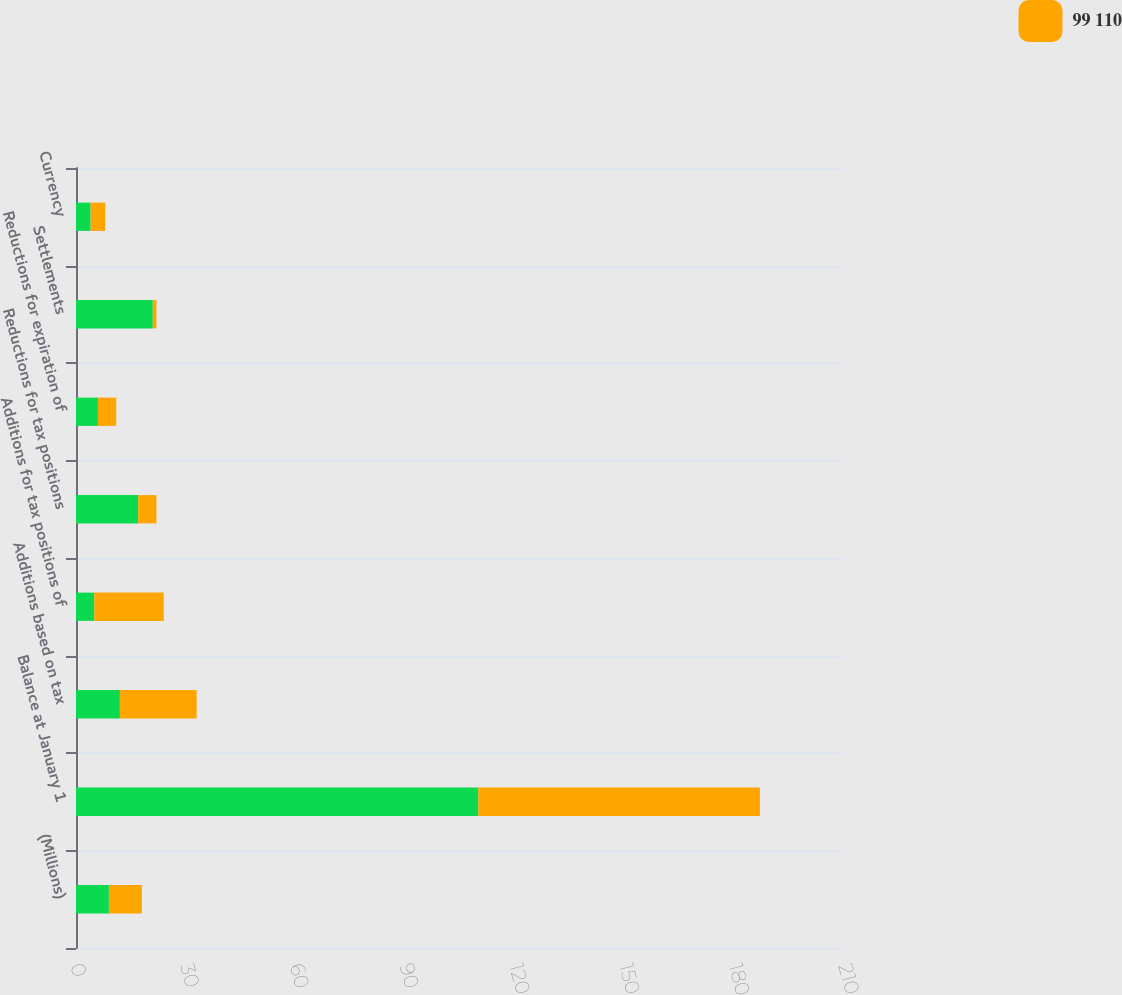Convert chart to OTSL. <chart><loc_0><loc_0><loc_500><loc_500><stacked_bar_chart><ecel><fcel>(Millions)<fcel>Balance at January 1<fcel>Additions based on tax<fcel>Additions for tax positions of<fcel>Reductions for tax positions<fcel>Reductions for expiration of<fcel>Settlements<fcel>Currency<nl><fcel>nan<fcel>9<fcel>110<fcel>12<fcel>5<fcel>17<fcel>6<fcel>21<fcel>4<nl><fcel>99 110<fcel>9<fcel>77<fcel>21<fcel>19<fcel>5<fcel>5<fcel>1<fcel>4<nl></chart> 